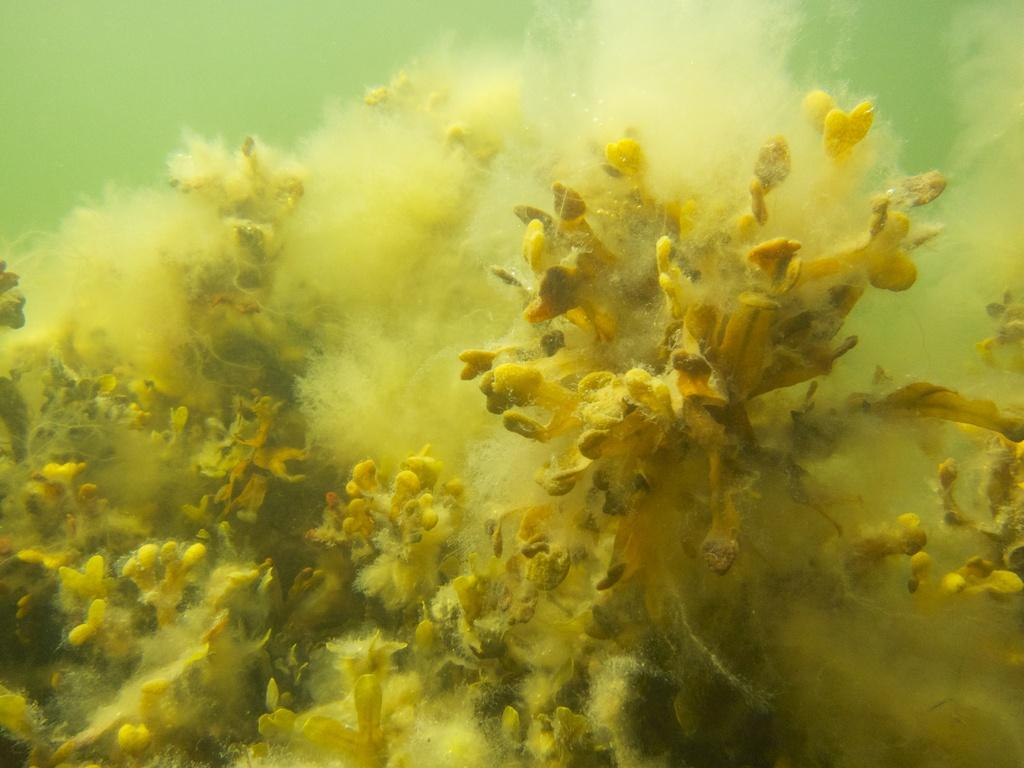What type of plants are in the image? There are water plants in the image. Where are the water plants located? The water plants are in the water. What type of payment method is accepted by the water plants in the image? There is no payment method mentioned or implied in the image, as it features water plants in the water. 